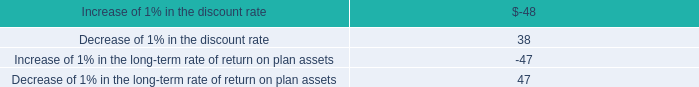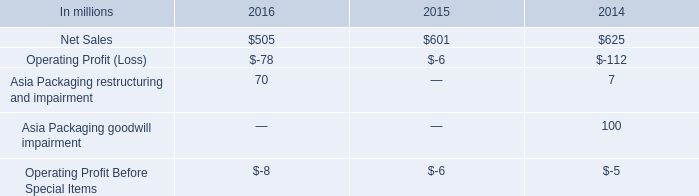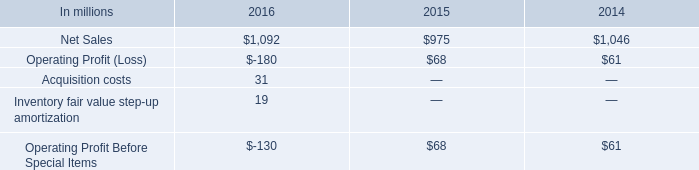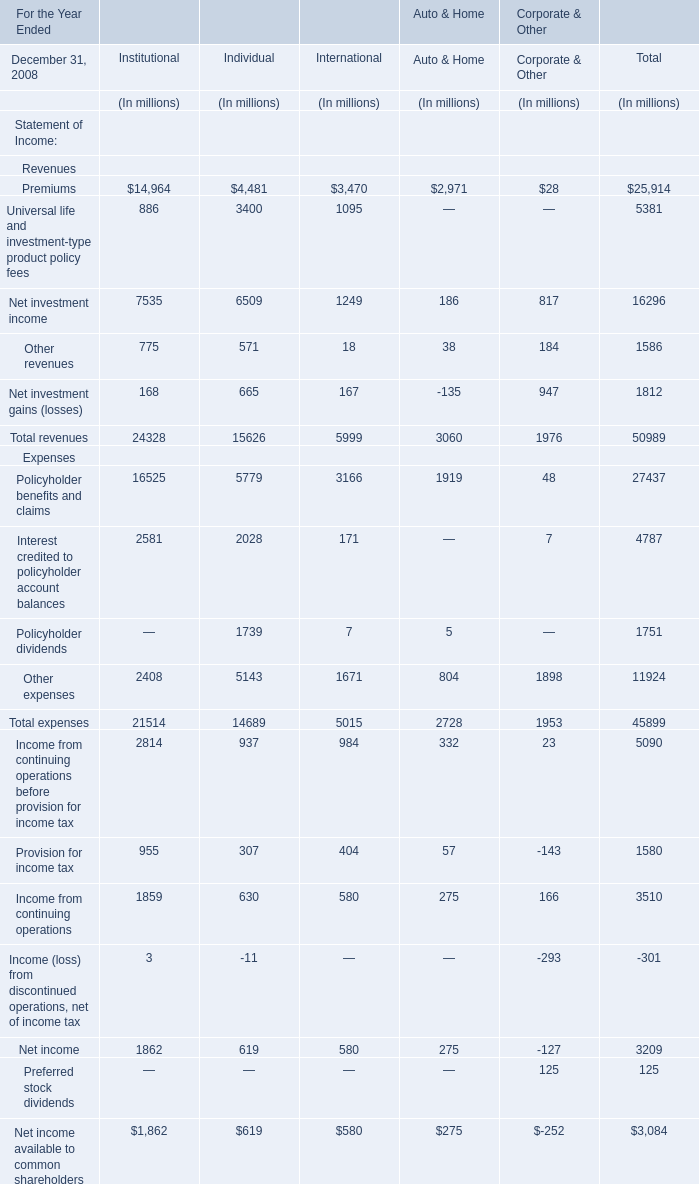What's the 30% of total revenues for Total in 2008? (in million) 
Computations: (50989 * 0.3)
Answer: 15296.7. 